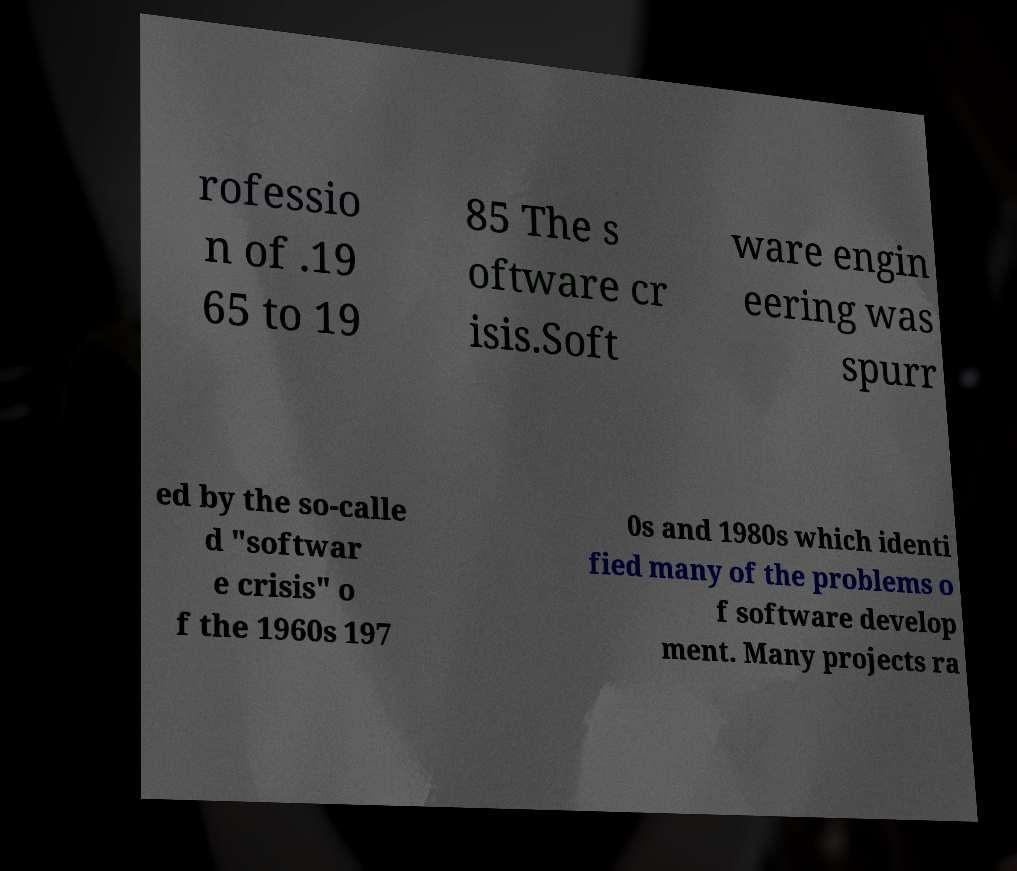What messages or text are displayed in this image? I need them in a readable, typed format. rofessio n of .19 65 to 19 85 The s oftware cr isis.Soft ware engin eering was spurr ed by the so-calle d "softwar e crisis" o f the 1960s 197 0s and 1980s which identi fied many of the problems o f software develop ment. Many projects ra 